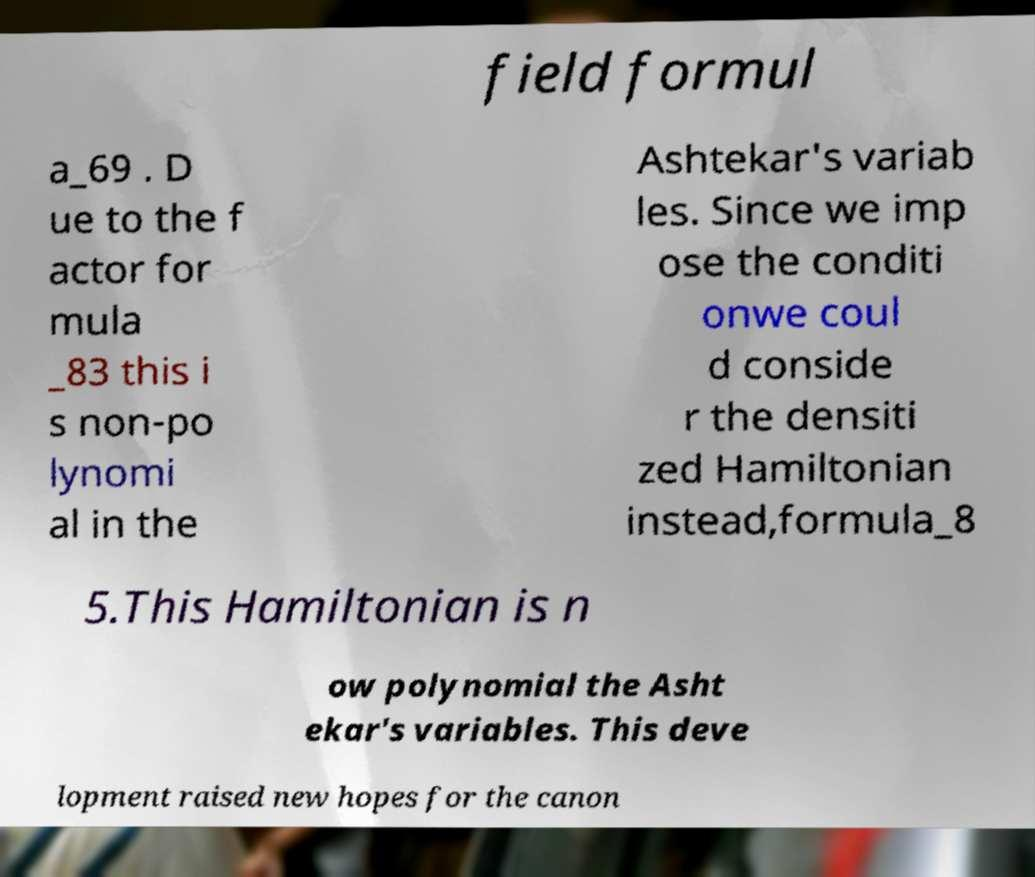For documentation purposes, I need the text within this image transcribed. Could you provide that? field formul a_69 . D ue to the f actor for mula _83 this i s non-po lynomi al in the Ashtekar's variab les. Since we imp ose the conditi onwe coul d conside r the densiti zed Hamiltonian instead,formula_8 5.This Hamiltonian is n ow polynomial the Asht ekar's variables. This deve lopment raised new hopes for the canon 